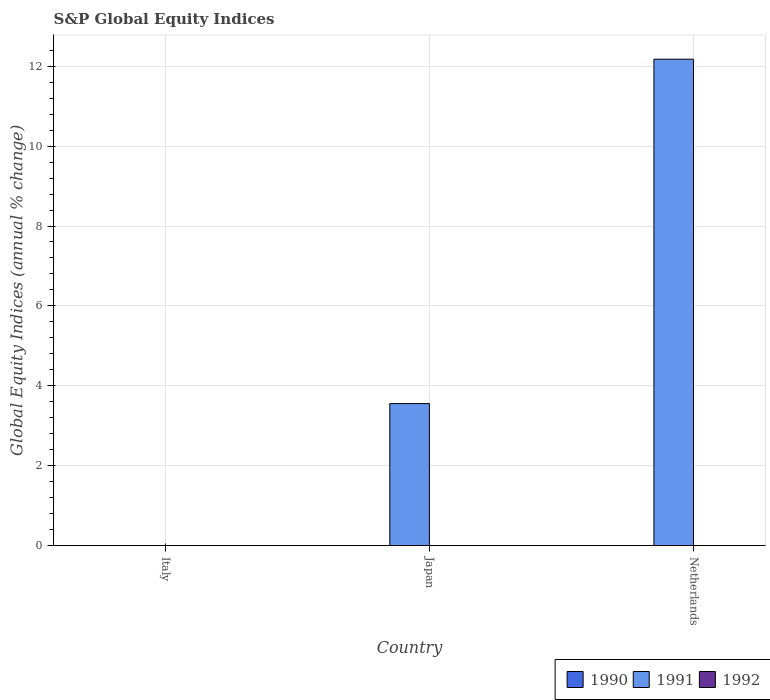Are the number of bars per tick equal to the number of legend labels?
Your response must be concise. No. Are the number of bars on each tick of the X-axis equal?
Offer a terse response. No. How many bars are there on the 2nd tick from the right?
Offer a terse response. 1. In how many cases, is the number of bars for a given country not equal to the number of legend labels?
Make the answer very short. 3. What is the global equity indices in 1991 in Japan?
Make the answer very short. 3.55. Across all countries, what is the maximum global equity indices in 1991?
Provide a short and direct response. 12.18. Across all countries, what is the minimum global equity indices in 1990?
Offer a terse response. 0. What is the total global equity indices in 1991 in the graph?
Provide a short and direct response. 15.73. What is the difference between the global equity indices in 1991 in Japan and that in Netherlands?
Make the answer very short. -8.62. What is the difference between the global equity indices in 1992 in Italy and the global equity indices in 1991 in Japan?
Provide a short and direct response. -3.55. What is the average global equity indices in 1992 per country?
Make the answer very short. 0. In how many countries, is the global equity indices in 1990 greater than 1.6 %?
Offer a terse response. 0. What is the difference between the highest and the lowest global equity indices in 1991?
Ensure brevity in your answer.  12.18. Is it the case that in every country, the sum of the global equity indices in 1991 and global equity indices in 1992 is greater than the global equity indices in 1990?
Your answer should be compact. No. How many bars are there?
Your response must be concise. 2. Are all the bars in the graph horizontal?
Provide a short and direct response. No. Does the graph contain any zero values?
Your answer should be compact. Yes. How many legend labels are there?
Provide a succinct answer. 3. What is the title of the graph?
Offer a terse response. S&P Global Equity Indices. Does "1999" appear as one of the legend labels in the graph?
Make the answer very short. No. What is the label or title of the Y-axis?
Make the answer very short. Global Equity Indices (annual % change). What is the Global Equity Indices (annual % change) of 1990 in Italy?
Give a very brief answer. 0. What is the Global Equity Indices (annual % change) of 1990 in Japan?
Provide a short and direct response. 0. What is the Global Equity Indices (annual % change) in 1991 in Japan?
Provide a short and direct response. 3.55. What is the Global Equity Indices (annual % change) of 1992 in Japan?
Your answer should be compact. 0. What is the Global Equity Indices (annual % change) of 1991 in Netherlands?
Ensure brevity in your answer.  12.18. Across all countries, what is the maximum Global Equity Indices (annual % change) in 1991?
Ensure brevity in your answer.  12.18. Across all countries, what is the minimum Global Equity Indices (annual % change) in 1991?
Keep it short and to the point. 0. What is the total Global Equity Indices (annual % change) of 1991 in the graph?
Keep it short and to the point. 15.73. What is the total Global Equity Indices (annual % change) in 1992 in the graph?
Offer a very short reply. 0. What is the difference between the Global Equity Indices (annual % change) in 1991 in Japan and that in Netherlands?
Give a very brief answer. -8.62. What is the average Global Equity Indices (annual % change) of 1990 per country?
Give a very brief answer. 0. What is the average Global Equity Indices (annual % change) of 1991 per country?
Ensure brevity in your answer.  5.24. What is the ratio of the Global Equity Indices (annual % change) of 1991 in Japan to that in Netherlands?
Give a very brief answer. 0.29. What is the difference between the highest and the lowest Global Equity Indices (annual % change) in 1991?
Ensure brevity in your answer.  12.18. 